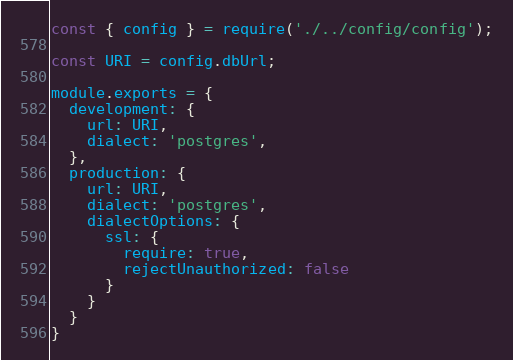<code> <loc_0><loc_0><loc_500><loc_500><_JavaScript_>const { config } = require('./../config/config');

const URI = config.dbUrl;

module.exports = {
  development: {
    url: URI,
    dialect: 'postgres',
  },
  production: {
    url: URI,
    dialect: 'postgres',
    dialectOptions: {
      ssl: {
        require: true,
        rejectUnauthorized: false
      }
    }
  }
}</code> 